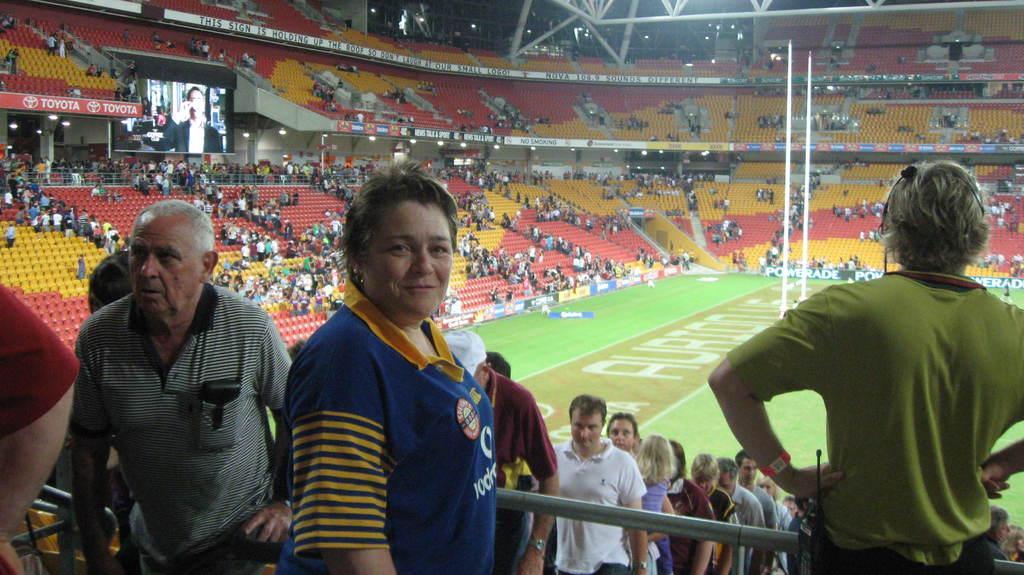Can you describe this image briefly? This picture describes about group of people, few are seated and few are standing, on the left side of the image we can see a screen, in the background we can find few metal rods. 